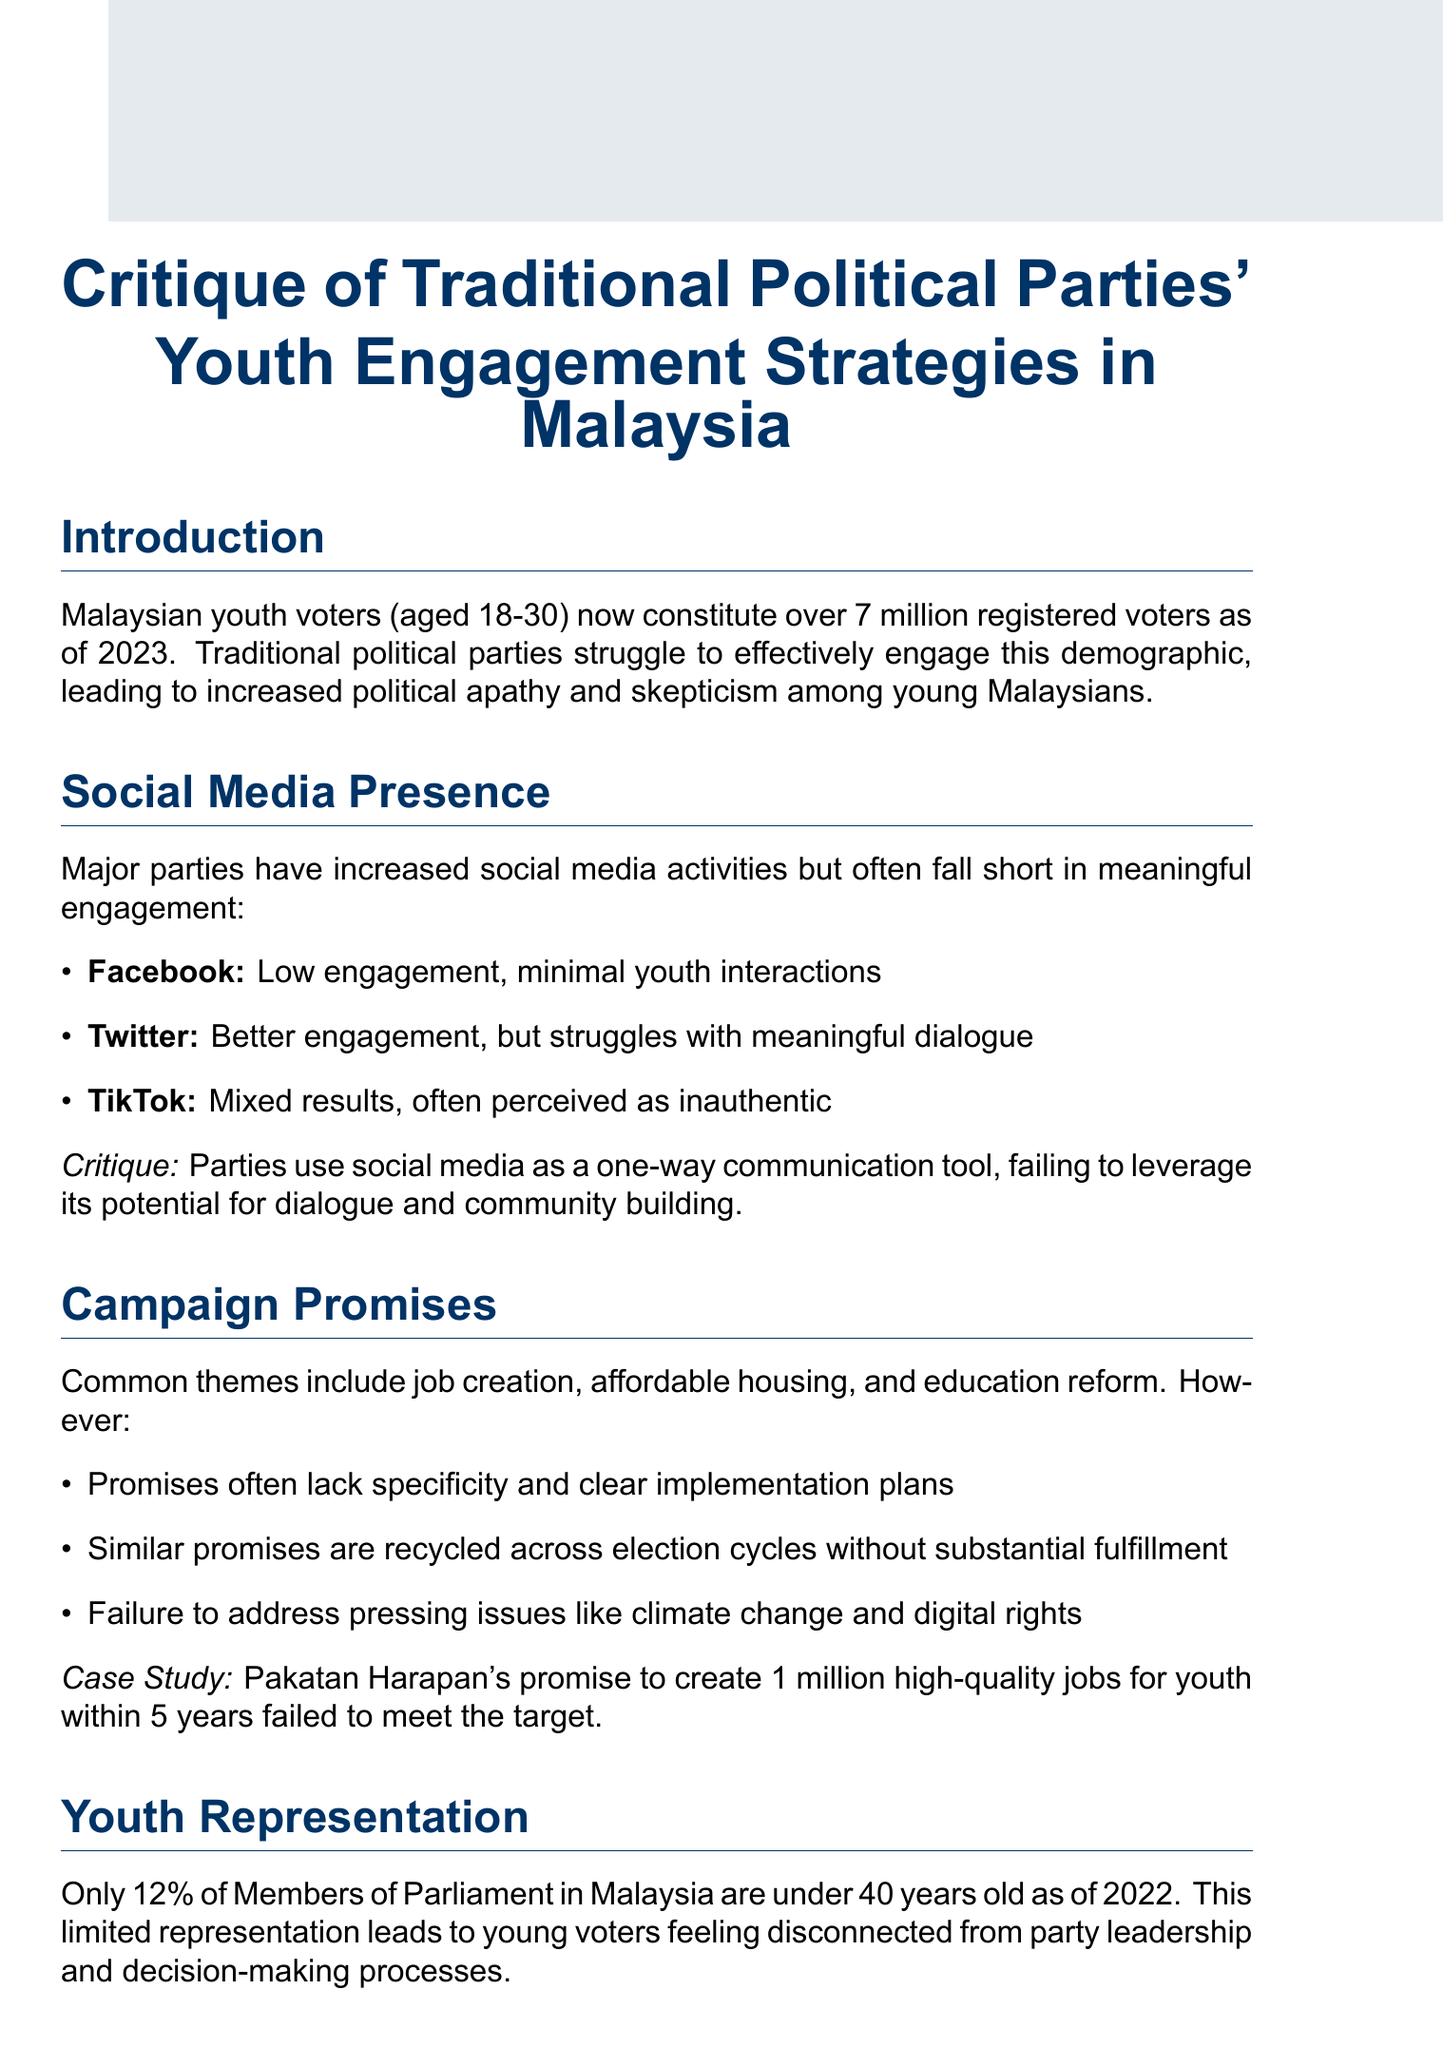what is the age range of Malaysian youth voters? The document states that Malaysian youth voters are aged 18-30.
Answer: 18-30 how many registered youth voters are there in Malaysia as of 2023? The document mentions there are over 7 million registered voters in this age group.
Answer: over 7 million which party's campaign promise involved creating 1 million jobs? The case study in the document refers to Pakatan Harapan's promise.
Answer: Pakatan Harapan what percentage of Members of Parliament are under 40 years old as of 2022? The document specifies that only 12% of Members of Parliament are under 40.
Answer: 12% what is a common theme in campaign promises targeting youth? The document lists job creation, affordable housing, and education reform as common themes.
Answer: Job creation what is the main critique of traditional political parties' use of social media? The document critiques parties for using social media as a one-way communication tool.
Answer: one-way communication tool what youth-led movement is mentioned in the document? The document references the Undi18 movement as an example.
Answer: Undi18 what do issue-based campaigns focus on? The document describes that they focus on specific issues rather than party loyalty.
Answer: specific issues what is a significant outcome of the youth engagement strategies? The document indicates that there is increased political apathy and skepticism among young Malaysians.
Answer: political apathy and skepticism 